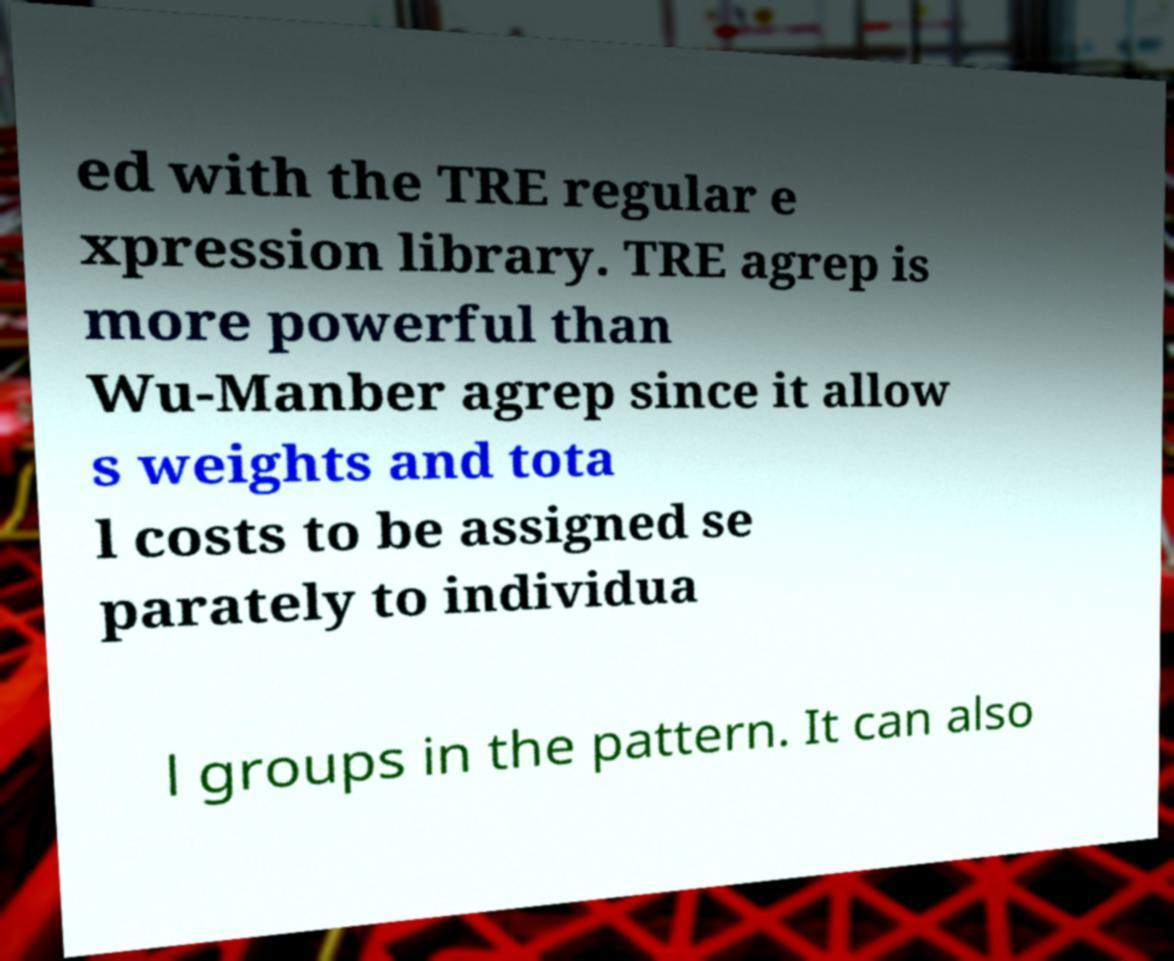What messages or text are displayed in this image? I need them in a readable, typed format. ed with the TRE regular e xpression library. TRE agrep is more powerful than Wu-Manber agrep since it allow s weights and tota l costs to be assigned se parately to individua l groups in the pattern. It can also 